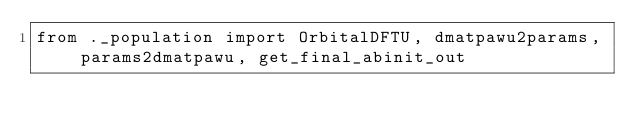<code> <loc_0><loc_0><loc_500><loc_500><_Python_>from ._population import OrbitalDFTU, dmatpawu2params, params2dmatpawu, get_final_abinit_out
</code> 